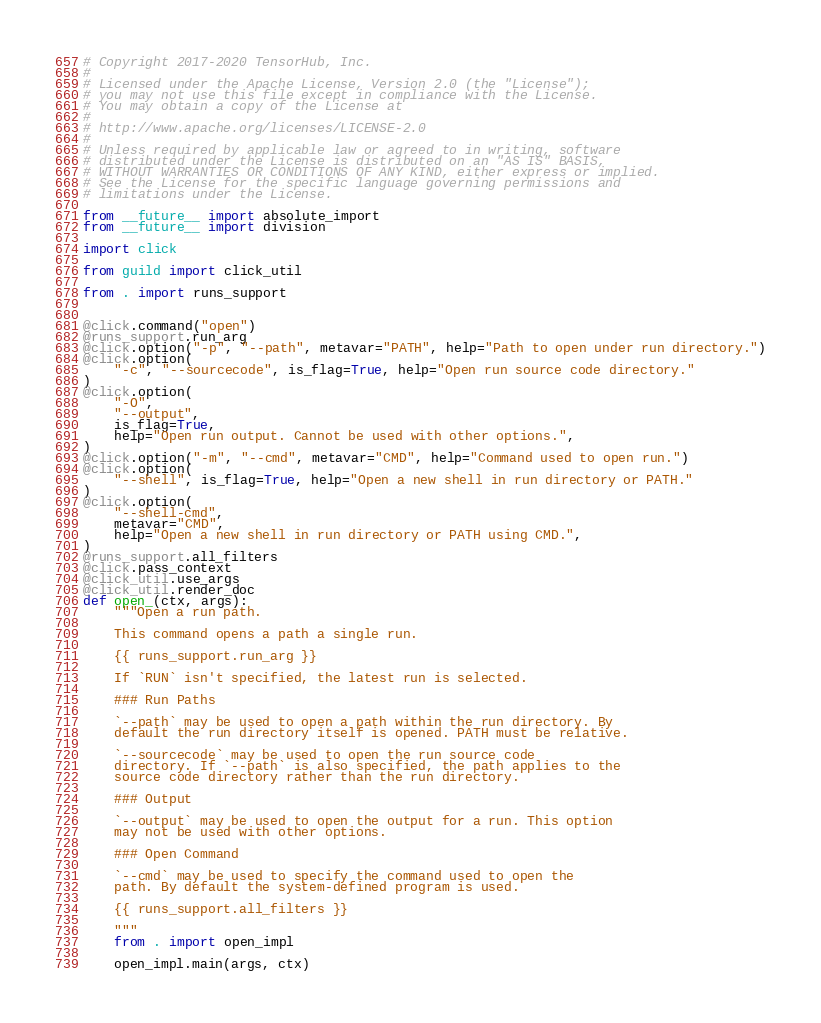Convert code to text. <code><loc_0><loc_0><loc_500><loc_500><_Python_># Copyright 2017-2020 TensorHub, Inc.
#
# Licensed under the Apache License, Version 2.0 (the "License");
# you may not use this file except in compliance with the License.
# You may obtain a copy of the License at
#
# http://www.apache.org/licenses/LICENSE-2.0
#
# Unless required by applicable law or agreed to in writing, software
# distributed under the License is distributed on an "AS IS" BASIS,
# WITHOUT WARRANTIES OR CONDITIONS OF ANY KIND, either express or implied.
# See the License for the specific language governing permissions and
# limitations under the License.

from __future__ import absolute_import
from __future__ import division

import click

from guild import click_util

from . import runs_support


@click.command("open")
@runs_support.run_arg
@click.option("-p", "--path", metavar="PATH", help="Path to open under run directory.")
@click.option(
    "-c", "--sourcecode", is_flag=True, help="Open run source code directory."
)
@click.option(
    "-O",
    "--output",
    is_flag=True,
    help="Open run output. Cannot be used with other options.",
)
@click.option("-m", "--cmd", metavar="CMD", help="Command used to open run.")
@click.option(
    "--shell", is_flag=True, help="Open a new shell in run directory or PATH."
)
@click.option(
    "--shell-cmd",
    metavar="CMD",
    help="Open a new shell in run directory or PATH using CMD.",
)
@runs_support.all_filters
@click.pass_context
@click_util.use_args
@click_util.render_doc
def open_(ctx, args):
    """Open a run path.

    This command opens a path a single run.

    {{ runs_support.run_arg }}

    If `RUN` isn't specified, the latest run is selected.

    ### Run Paths

    `--path` may be used to open a path within the run directory. By
    default the run directory itself is opened. PATH must be relative.

    `--sourcecode` may be used to open the run source code
    directory. If `--path` is also specified, the path applies to the
    source code directory rather than the run directory.

    ### Output

    `--output` may be used to open the output for a run. This option
    may not be used with other options.

    ### Open Command

    `--cmd` may be used to specify the command used to open the
    path. By default the system-defined program is used.

    {{ runs_support.all_filters }}

    """
    from . import open_impl

    open_impl.main(args, ctx)
</code> 